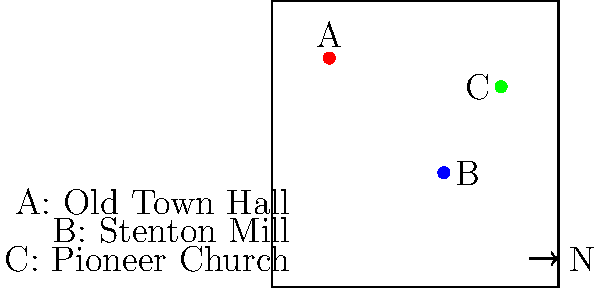Based on the vintage map of Stenton shown above, which forgotten landmark is located furthest north? To determine which landmark is furthest north, we need to follow these steps:

1. Understand the map orientation:
   - The arrow in the bottom right indicates that north is towards the top of the map.

2. Identify the landmarks:
   - A (red dot): Old Town Hall
   - B (blue dot): Stenton Mill
   - C (green dot): Pioneer Church

3. Compare the vertical positions of the landmarks:
   - A (Old Town Hall) is positioned highest on the map.
   - C (Pioneer Church) is the second highest.
   - B (Stenton Mill) is the lowest.

4. Conclude:
   - Since A (Old Town Hall) is positioned highest on the map and north is towards the top, the Old Town Hall is the furthest north among the three landmarks.
Answer: Old Town Hall 